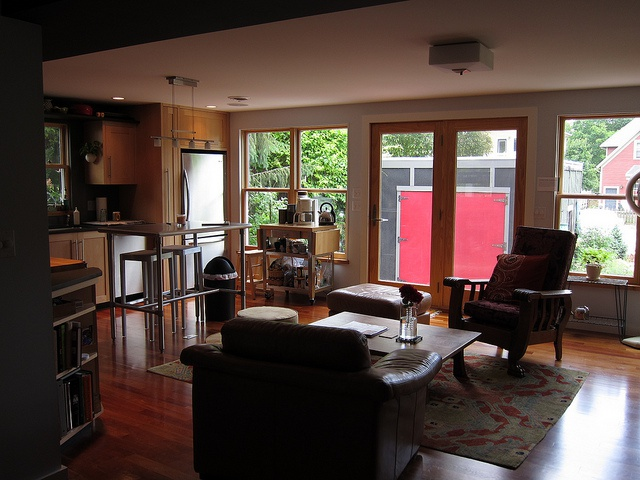Describe the objects in this image and their specific colors. I can see chair in black, gray, darkgray, and maroon tones, couch in black, gray, and darkgray tones, chair in black, maroon, gray, and lightgray tones, refrigerator in black, white, darkgray, and gray tones, and chair in black, gray, maroon, and darkgray tones in this image. 